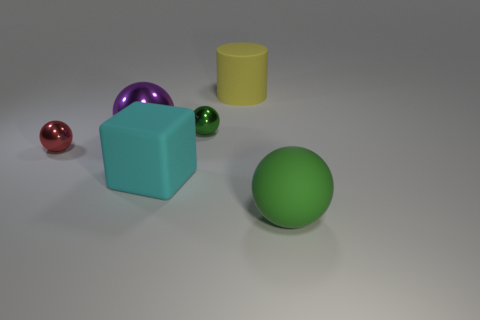Subtract all tiny red balls. How many balls are left? 3 Subtract 3 spheres. How many spheres are left? 1 Subtract all green balls. How many balls are left? 2 Add 2 yellow rubber balls. How many objects exist? 8 Subtract all cylinders. How many objects are left? 5 Add 6 yellow things. How many yellow things exist? 7 Subtract 0 cyan balls. How many objects are left? 6 Subtract all green spheres. Subtract all brown blocks. How many spheres are left? 2 Subtract all gray cylinders. How many green balls are left? 2 Subtract all tiny metal objects. Subtract all small green blocks. How many objects are left? 4 